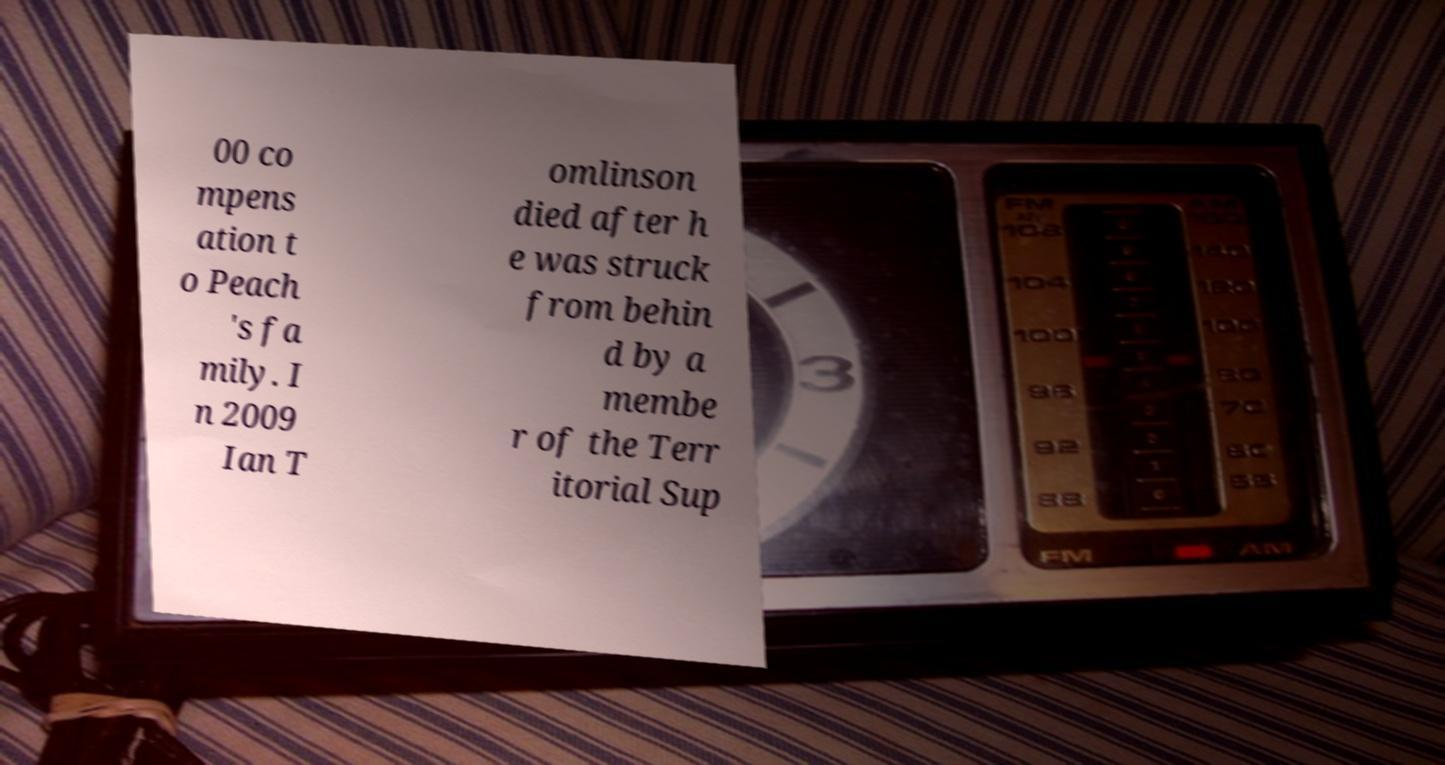There's text embedded in this image that I need extracted. Can you transcribe it verbatim? 00 co mpens ation t o Peach 's fa mily. I n 2009 Ian T omlinson died after h e was struck from behin d by a membe r of the Terr itorial Sup 